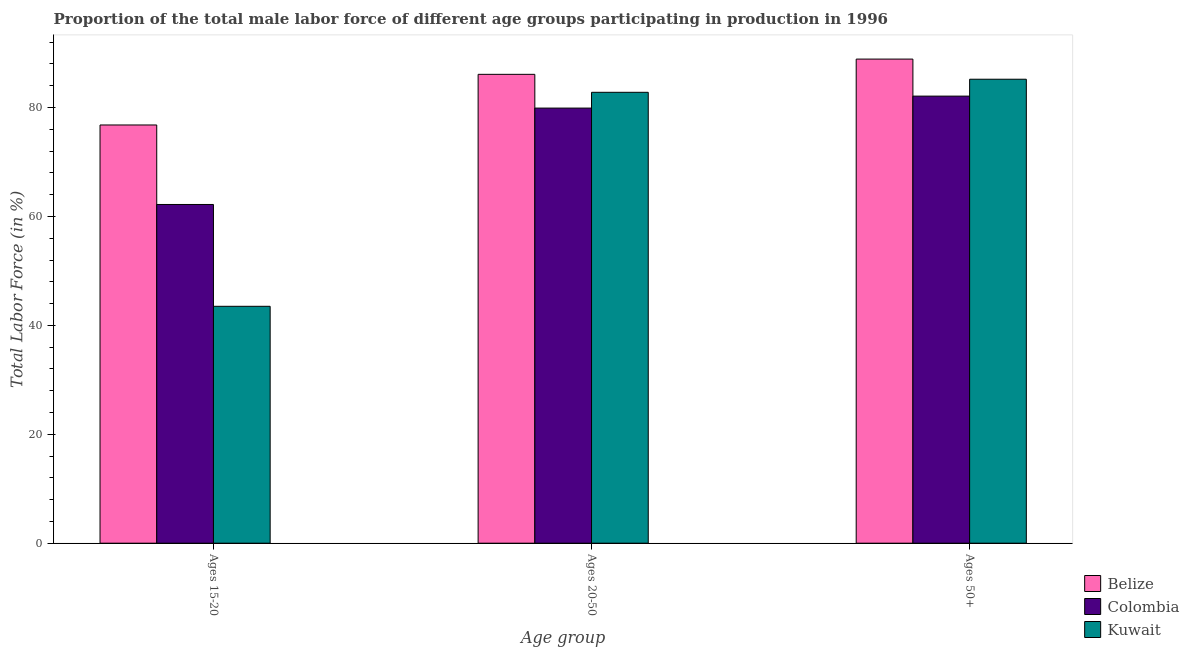How many different coloured bars are there?
Make the answer very short. 3. How many groups of bars are there?
Offer a terse response. 3. Are the number of bars per tick equal to the number of legend labels?
Your answer should be compact. Yes. What is the label of the 1st group of bars from the left?
Keep it short and to the point. Ages 15-20. What is the percentage of male labor force within the age group 20-50 in Belize?
Provide a short and direct response. 86.1. Across all countries, what is the maximum percentage of male labor force above age 50?
Provide a short and direct response. 88.9. Across all countries, what is the minimum percentage of male labor force within the age group 15-20?
Your response must be concise. 43.5. In which country was the percentage of male labor force above age 50 maximum?
Ensure brevity in your answer.  Belize. In which country was the percentage of male labor force above age 50 minimum?
Ensure brevity in your answer.  Colombia. What is the total percentage of male labor force within the age group 15-20 in the graph?
Ensure brevity in your answer.  182.5. What is the difference between the percentage of male labor force within the age group 15-20 in Kuwait and that in Colombia?
Offer a terse response. -18.7. What is the difference between the percentage of male labor force above age 50 in Colombia and the percentage of male labor force within the age group 15-20 in Belize?
Your answer should be compact. 5.3. What is the average percentage of male labor force above age 50 per country?
Your answer should be very brief. 85.4. What is the difference between the percentage of male labor force within the age group 15-20 and percentage of male labor force above age 50 in Colombia?
Offer a terse response. -19.9. What is the ratio of the percentage of male labor force within the age group 20-50 in Colombia to that in Belize?
Provide a short and direct response. 0.93. Is the percentage of male labor force above age 50 in Colombia less than that in Kuwait?
Make the answer very short. Yes. Is the difference between the percentage of male labor force within the age group 15-20 in Belize and Kuwait greater than the difference between the percentage of male labor force within the age group 20-50 in Belize and Kuwait?
Keep it short and to the point. Yes. What is the difference between the highest and the second highest percentage of male labor force within the age group 15-20?
Make the answer very short. 14.6. What is the difference between the highest and the lowest percentage of male labor force within the age group 20-50?
Make the answer very short. 6.2. Is the sum of the percentage of male labor force above age 50 in Colombia and Belize greater than the maximum percentage of male labor force within the age group 20-50 across all countries?
Give a very brief answer. Yes. What does the 1st bar from the left in Ages 50+ represents?
Offer a terse response. Belize. Are all the bars in the graph horizontal?
Make the answer very short. No. How many countries are there in the graph?
Provide a succinct answer. 3. Does the graph contain any zero values?
Provide a succinct answer. No. Does the graph contain grids?
Offer a very short reply. No. How many legend labels are there?
Ensure brevity in your answer.  3. How are the legend labels stacked?
Your response must be concise. Vertical. What is the title of the graph?
Offer a terse response. Proportion of the total male labor force of different age groups participating in production in 1996. Does "Croatia" appear as one of the legend labels in the graph?
Provide a succinct answer. No. What is the label or title of the X-axis?
Provide a short and direct response. Age group. What is the Total Labor Force (in %) in Belize in Ages 15-20?
Provide a short and direct response. 76.8. What is the Total Labor Force (in %) in Colombia in Ages 15-20?
Offer a terse response. 62.2. What is the Total Labor Force (in %) of Kuwait in Ages 15-20?
Provide a succinct answer. 43.5. What is the Total Labor Force (in %) in Belize in Ages 20-50?
Give a very brief answer. 86.1. What is the Total Labor Force (in %) in Colombia in Ages 20-50?
Your answer should be compact. 79.9. What is the Total Labor Force (in %) in Kuwait in Ages 20-50?
Make the answer very short. 82.8. What is the Total Labor Force (in %) of Belize in Ages 50+?
Provide a succinct answer. 88.9. What is the Total Labor Force (in %) of Colombia in Ages 50+?
Make the answer very short. 82.1. What is the Total Labor Force (in %) in Kuwait in Ages 50+?
Make the answer very short. 85.2. Across all Age group, what is the maximum Total Labor Force (in %) of Belize?
Keep it short and to the point. 88.9. Across all Age group, what is the maximum Total Labor Force (in %) in Colombia?
Provide a short and direct response. 82.1. Across all Age group, what is the maximum Total Labor Force (in %) in Kuwait?
Ensure brevity in your answer.  85.2. Across all Age group, what is the minimum Total Labor Force (in %) in Belize?
Provide a short and direct response. 76.8. Across all Age group, what is the minimum Total Labor Force (in %) of Colombia?
Your answer should be very brief. 62.2. Across all Age group, what is the minimum Total Labor Force (in %) of Kuwait?
Make the answer very short. 43.5. What is the total Total Labor Force (in %) in Belize in the graph?
Your answer should be compact. 251.8. What is the total Total Labor Force (in %) of Colombia in the graph?
Keep it short and to the point. 224.2. What is the total Total Labor Force (in %) of Kuwait in the graph?
Keep it short and to the point. 211.5. What is the difference between the Total Labor Force (in %) in Belize in Ages 15-20 and that in Ages 20-50?
Your answer should be very brief. -9.3. What is the difference between the Total Labor Force (in %) in Colombia in Ages 15-20 and that in Ages 20-50?
Provide a succinct answer. -17.7. What is the difference between the Total Labor Force (in %) in Kuwait in Ages 15-20 and that in Ages 20-50?
Offer a very short reply. -39.3. What is the difference between the Total Labor Force (in %) in Belize in Ages 15-20 and that in Ages 50+?
Provide a short and direct response. -12.1. What is the difference between the Total Labor Force (in %) in Colombia in Ages 15-20 and that in Ages 50+?
Offer a very short reply. -19.9. What is the difference between the Total Labor Force (in %) in Kuwait in Ages 15-20 and that in Ages 50+?
Give a very brief answer. -41.7. What is the difference between the Total Labor Force (in %) in Kuwait in Ages 20-50 and that in Ages 50+?
Keep it short and to the point. -2.4. What is the difference between the Total Labor Force (in %) of Colombia in Ages 15-20 and the Total Labor Force (in %) of Kuwait in Ages 20-50?
Provide a succinct answer. -20.6. What is the difference between the Total Labor Force (in %) of Belize in Ages 15-20 and the Total Labor Force (in %) of Colombia in Ages 50+?
Make the answer very short. -5.3. What is the difference between the Total Labor Force (in %) of Belize in Ages 15-20 and the Total Labor Force (in %) of Kuwait in Ages 50+?
Your answer should be compact. -8.4. What is the difference between the Total Labor Force (in %) in Colombia in Ages 15-20 and the Total Labor Force (in %) in Kuwait in Ages 50+?
Give a very brief answer. -23. What is the difference between the Total Labor Force (in %) of Belize in Ages 20-50 and the Total Labor Force (in %) of Colombia in Ages 50+?
Provide a short and direct response. 4. What is the average Total Labor Force (in %) in Belize per Age group?
Ensure brevity in your answer.  83.93. What is the average Total Labor Force (in %) of Colombia per Age group?
Your response must be concise. 74.73. What is the average Total Labor Force (in %) in Kuwait per Age group?
Give a very brief answer. 70.5. What is the difference between the Total Labor Force (in %) of Belize and Total Labor Force (in %) of Kuwait in Ages 15-20?
Your response must be concise. 33.3. What is the difference between the Total Labor Force (in %) in Colombia and Total Labor Force (in %) in Kuwait in Ages 15-20?
Offer a terse response. 18.7. What is the ratio of the Total Labor Force (in %) in Belize in Ages 15-20 to that in Ages 20-50?
Give a very brief answer. 0.89. What is the ratio of the Total Labor Force (in %) of Colombia in Ages 15-20 to that in Ages 20-50?
Your answer should be compact. 0.78. What is the ratio of the Total Labor Force (in %) of Kuwait in Ages 15-20 to that in Ages 20-50?
Your answer should be very brief. 0.53. What is the ratio of the Total Labor Force (in %) in Belize in Ages 15-20 to that in Ages 50+?
Make the answer very short. 0.86. What is the ratio of the Total Labor Force (in %) of Colombia in Ages 15-20 to that in Ages 50+?
Provide a succinct answer. 0.76. What is the ratio of the Total Labor Force (in %) in Kuwait in Ages 15-20 to that in Ages 50+?
Your answer should be very brief. 0.51. What is the ratio of the Total Labor Force (in %) of Belize in Ages 20-50 to that in Ages 50+?
Offer a terse response. 0.97. What is the ratio of the Total Labor Force (in %) of Colombia in Ages 20-50 to that in Ages 50+?
Your answer should be compact. 0.97. What is the ratio of the Total Labor Force (in %) of Kuwait in Ages 20-50 to that in Ages 50+?
Offer a very short reply. 0.97. What is the difference between the highest and the second highest Total Labor Force (in %) in Belize?
Offer a terse response. 2.8. What is the difference between the highest and the second highest Total Labor Force (in %) of Colombia?
Your response must be concise. 2.2. What is the difference between the highest and the lowest Total Labor Force (in %) of Kuwait?
Your response must be concise. 41.7. 